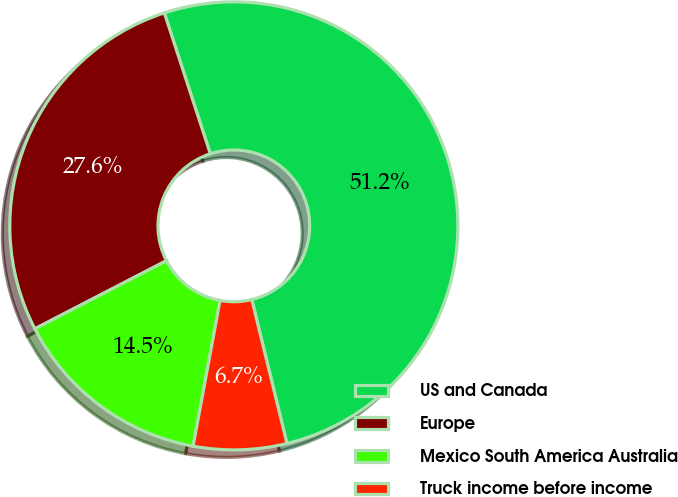Convert chart to OTSL. <chart><loc_0><loc_0><loc_500><loc_500><pie_chart><fcel>US and Canada<fcel>Europe<fcel>Mexico South America Australia<fcel>Truck income before income<nl><fcel>51.21%<fcel>27.58%<fcel>14.49%<fcel>6.72%<nl></chart> 